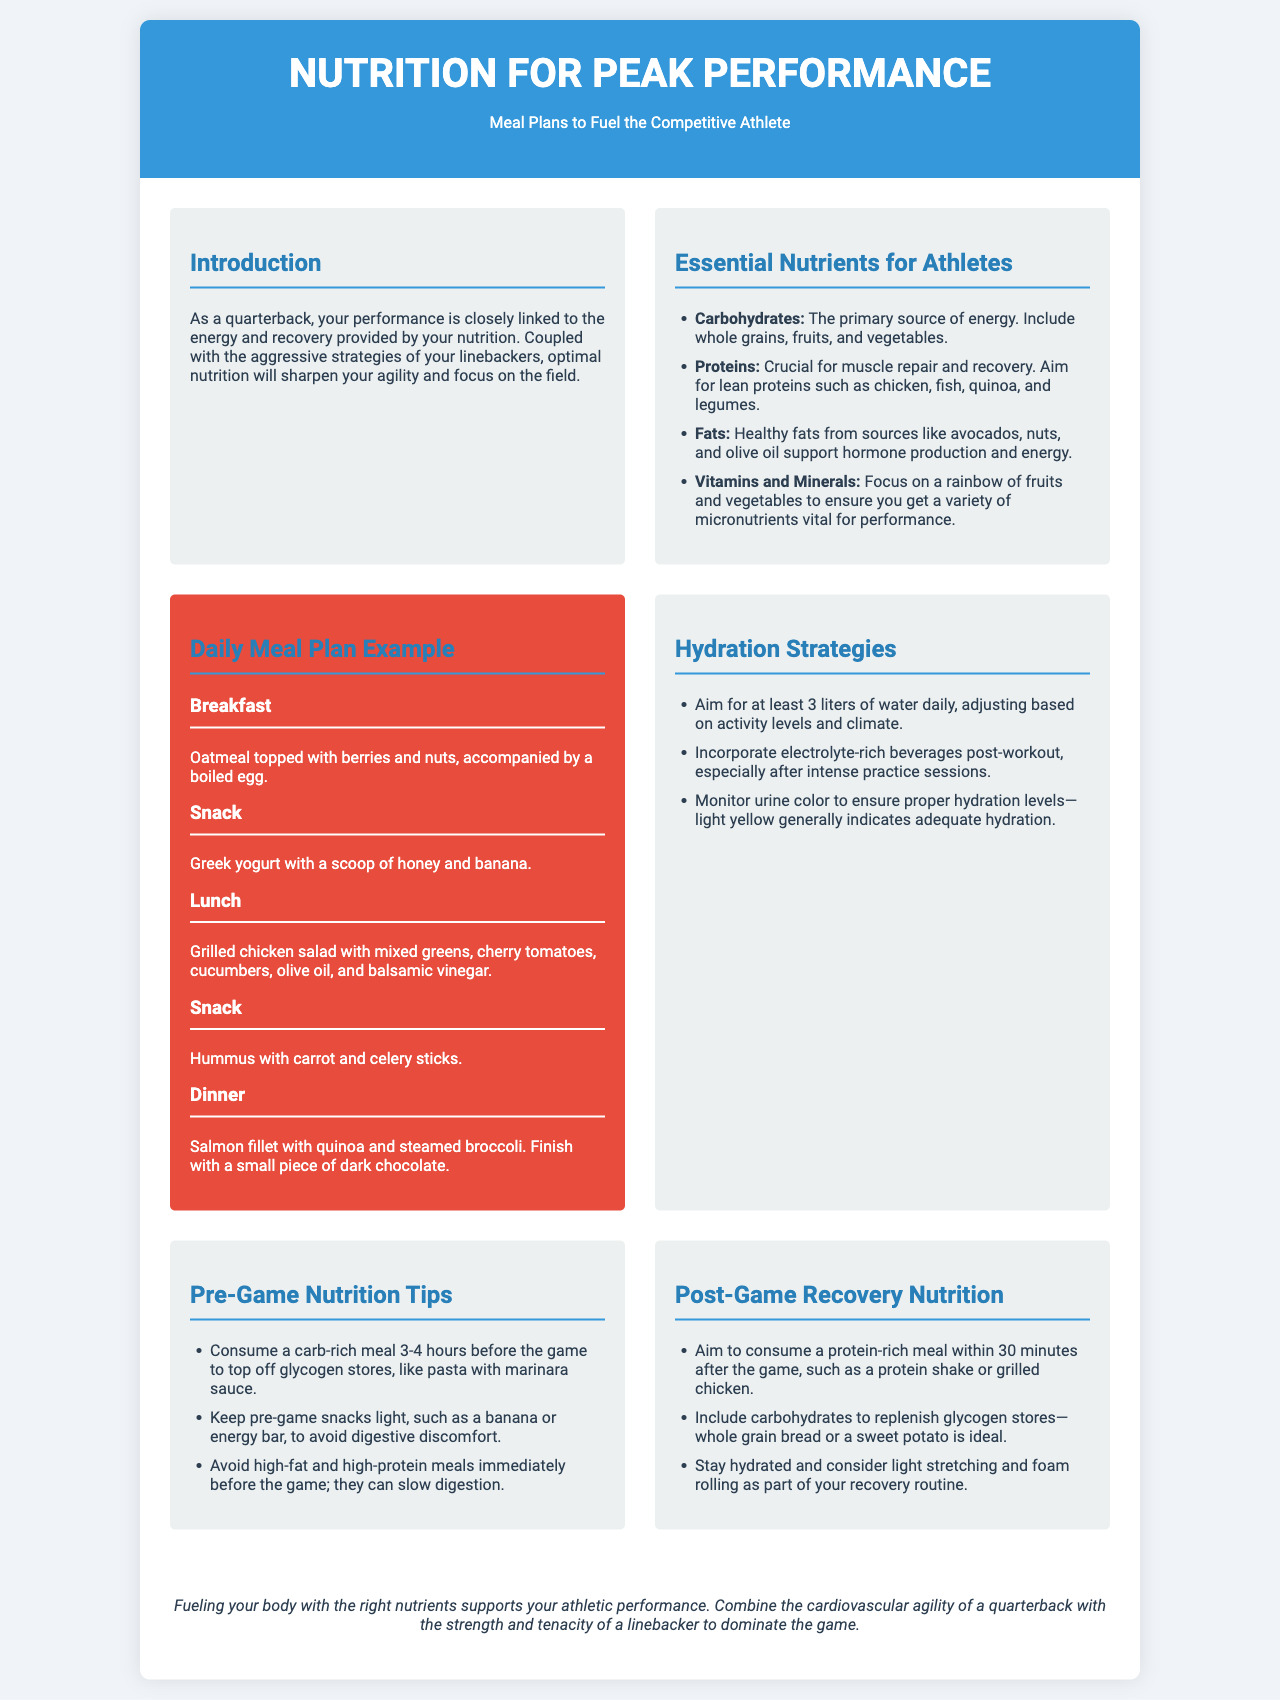what is the primary source of energy for athletes? The primary source of energy for athletes is carbohydrates, as stated in the "Essential Nutrients for Athletes" section.
Answer: carbohydrates what should a quarterback include in their pre-game meal? The pre-game meal should be carb-rich, as detailed in the "Pre-Game Nutrition Tips" section.
Answer: carb-rich meal how many liters of water should athletes aim for daily? Athletes should aim for at least 3 liters of water daily, based on the "Hydration Strategies" section.
Answer: 3 liters what is a suggested post-game recovery meal? A suggested post-game recovery meal is a protein-rich meal, such as a protein shake or grilled chicken, from the "Post-Game Recovery Nutrition" section.
Answer: protein-rich meal what is recommended to monitor hydration levels? It is recommended to monitor urine color to ensure proper hydration levels, as mentioned in the "Hydration Strategies" section.
Answer: urine color how does proper nutrition influence performance? Proper nutrition supports athletic performance, indicated in the conclusion of the brochure.
Answer: supports performance what type of fats should athletes focus on? Athletes should focus on healthy fats, as mentioned in the "Essential Nutrients for Athletes" section.
Answer: healthy fats what is the ideal carbohydrate source for recovery after a game? The ideal carbohydrate source for recovery is whole grain bread or a sweet potato, according to the "Post-Game Recovery Nutrition" section.
Answer: whole grain bread where can you find a detailed daily meal plan example? A detailed daily meal plan example is found in the "Daily Meal Plan Example" section of the brochure.
Answer: Daily Meal Plan Example 